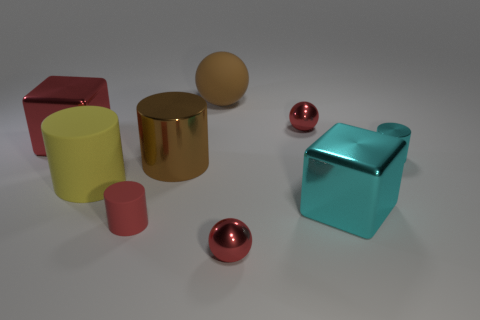Is the number of small metallic objects that are behind the yellow thing greater than the number of red cylinders? yes 